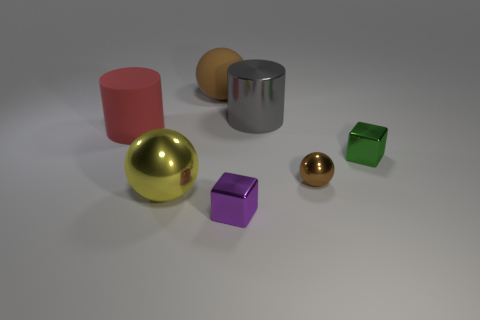Can you tell me the different shapes and colors visible in this image? Certainly! The image displays a variety of shapes including cylinders, spheres, and cubes, with colors such as red, gold, silver, orange, green, and purple. 